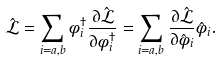<formula> <loc_0><loc_0><loc_500><loc_500>\hat { \mathcal { L } } = \sum _ { i = a , b } { \phi } ^ { \dagger } _ { i } \frac { \partial \hat { \mathcal { L } } } { \partial { \phi } ^ { \dagger } _ { i } } = \sum _ { i = a , b } \frac { \partial \hat { \mathcal { L } } } { \partial { \hat { \phi } } _ { i } } { \hat { \phi } } _ { i } .</formula> 